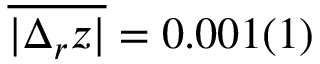Convert formula to latex. <formula><loc_0><loc_0><loc_500><loc_500>\overline { { | \Delta _ { r } z | } } = 0 . 0 0 1 ( 1 )</formula> 